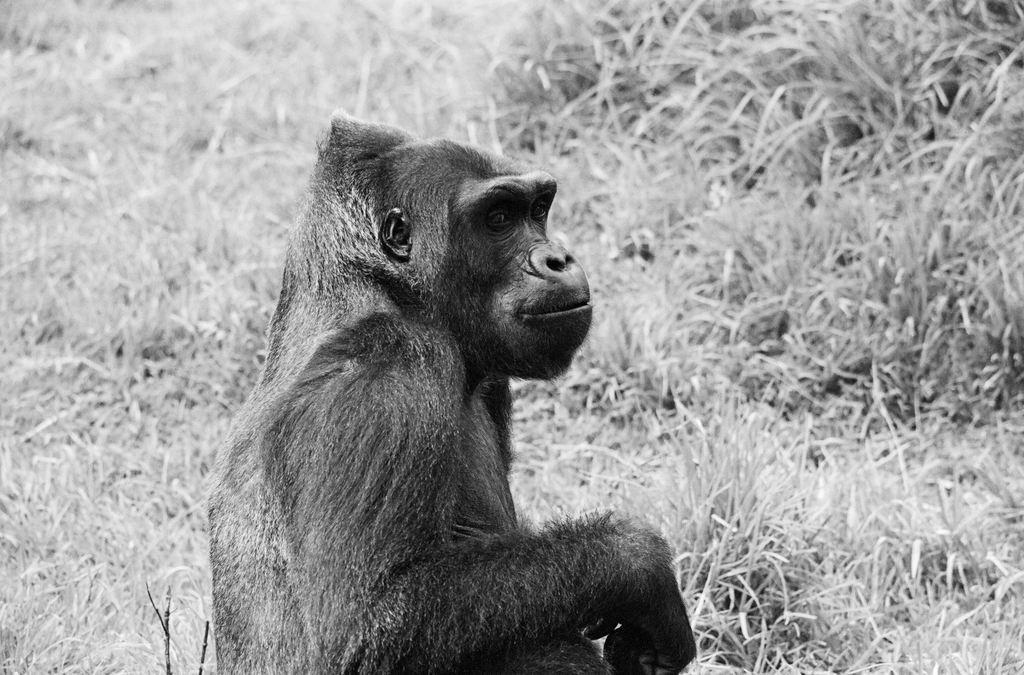What is the color scheme of the image? The image is black and white. What animal can be seen in the image? There is a chimpanzee in the image. What type of vegetation is visible in the background of the image? There is grass in the background of the image. What type of carpenter tool can be seen in the image? There are no carpenter tools present in the image. What is the texture of the tin in the image? There is no tin present in the image. 